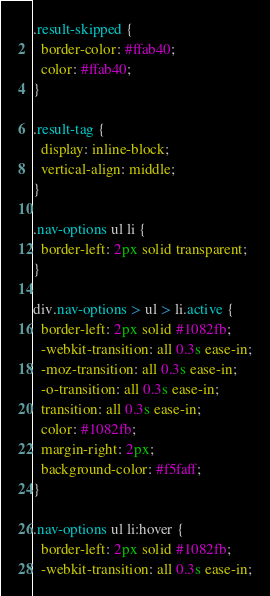Convert code to text. <code><loc_0><loc_0><loc_500><loc_500><_CSS_>
.result-skipped {
  border-color: #ffab40;
  color: #ffab40;
}

.result-tag {
  display: inline-block;
  vertical-align: middle;
}

.nav-options ul li {
  border-left: 2px solid transparent;
}

div.nav-options > ul > li.active {
  border-left: 2px solid #1082fb;
  -webkit-transition: all 0.3s ease-in;
  -moz-transition: all 0.3s ease-in;
  -o-transition: all 0.3s ease-in;
  transition: all 0.3s ease-in;
  color: #1082fb;
  margin-right: 2px;
  background-color: #f5faff;
}

.nav-options ul li:hover {
  border-left: 2px solid #1082fb;
  -webkit-transition: all 0.3s ease-in;</code> 